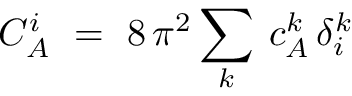<formula> <loc_0><loc_0><loc_500><loc_500>C _ { A } ^ { i } \ = \ 8 \, \pi ^ { 2 } \sum _ { k } \, c _ { A } ^ { k } \, \delta _ { i } ^ { k }</formula> 